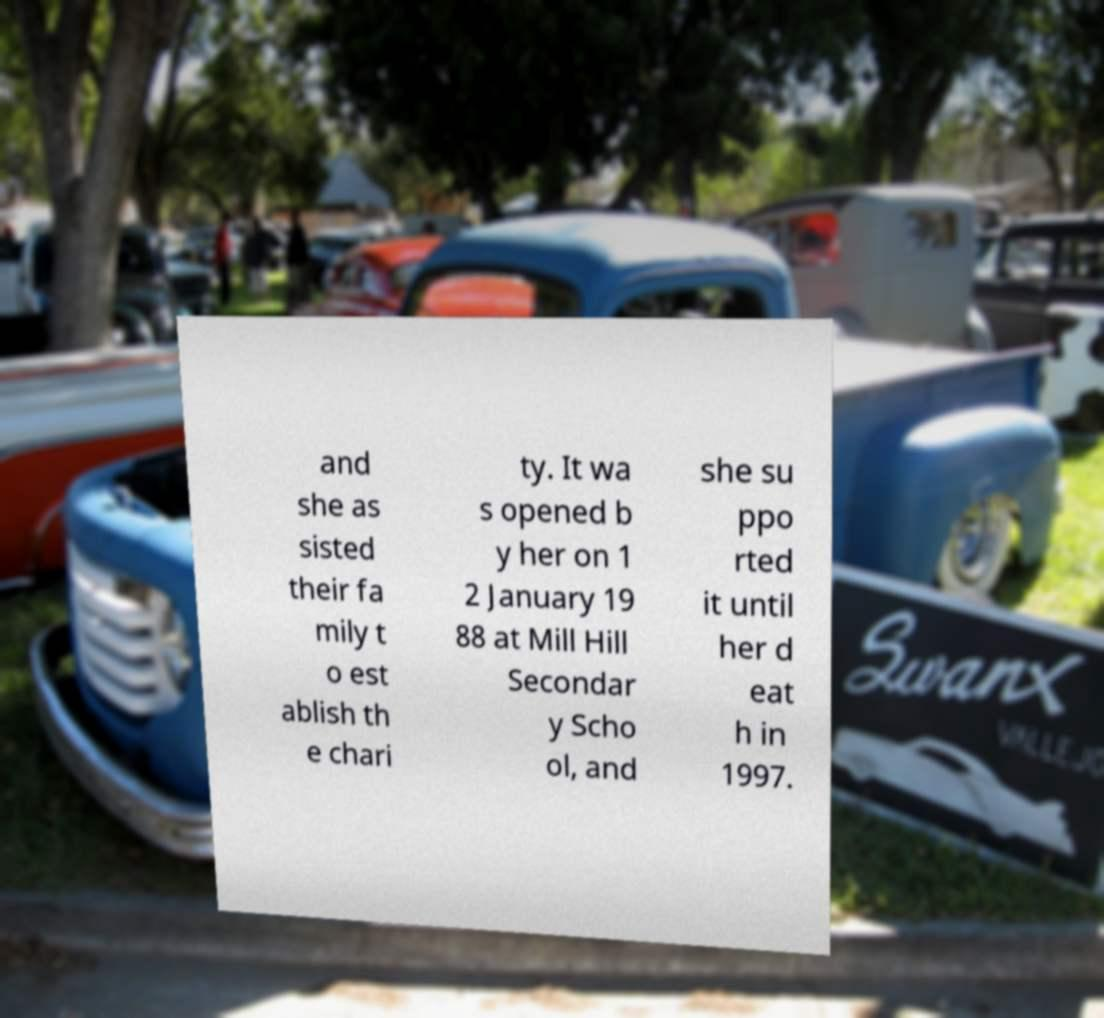Please identify and transcribe the text found in this image. and she as sisted their fa mily t o est ablish th e chari ty. It wa s opened b y her on 1 2 January 19 88 at Mill Hill Secondar y Scho ol, and she su ppo rted it until her d eat h in 1997. 